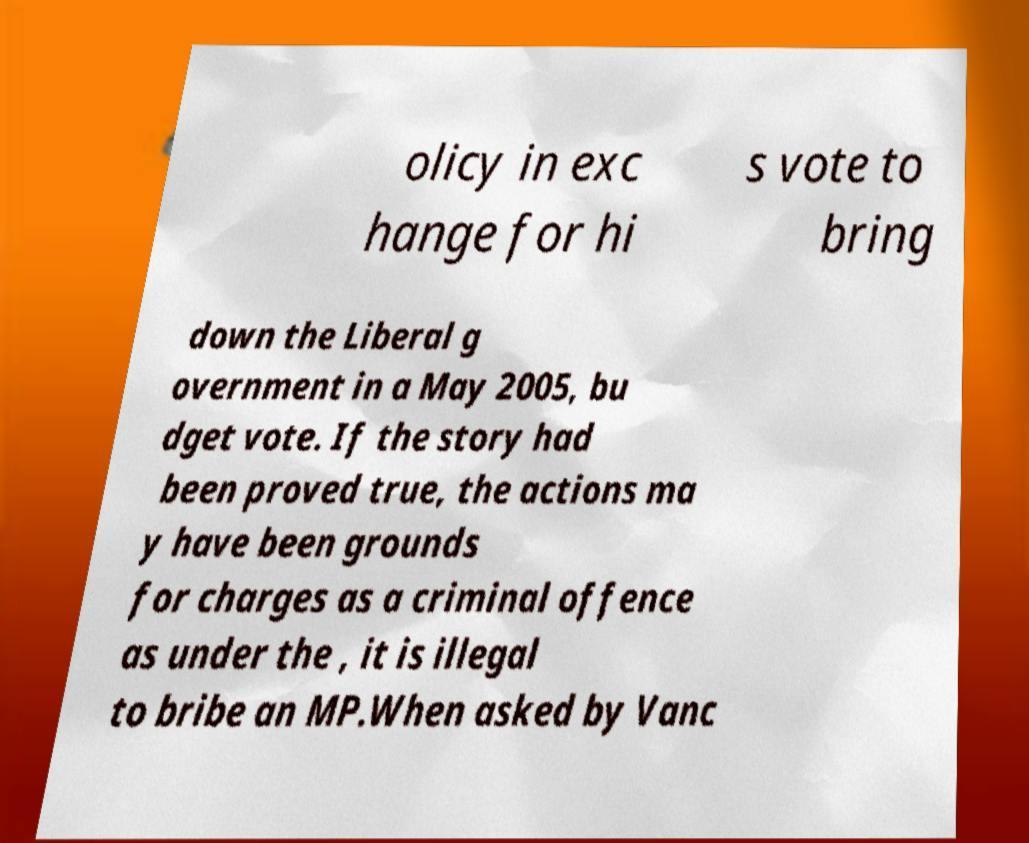What messages or text are displayed in this image? I need them in a readable, typed format. olicy in exc hange for hi s vote to bring down the Liberal g overnment in a May 2005, bu dget vote. If the story had been proved true, the actions ma y have been grounds for charges as a criminal offence as under the , it is illegal to bribe an MP.When asked by Vanc 